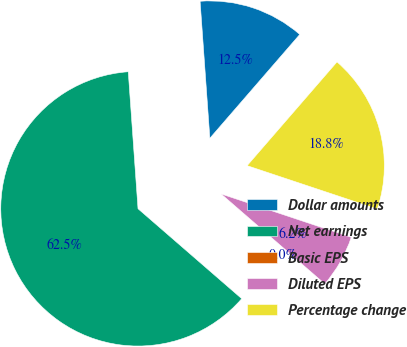<chart> <loc_0><loc_0><loc_500><loc_500><pie_chart><fcel>Dollar amounts<fcel>Net earnings<fcel>Basic EPS<fcel>Diluted EPS<fcel>Percentage change<nl><fcel>12.5%<fcel>62.5%<fcel>0.0%<fcel>6.25%<fcel>18.75%<nl></chart> 